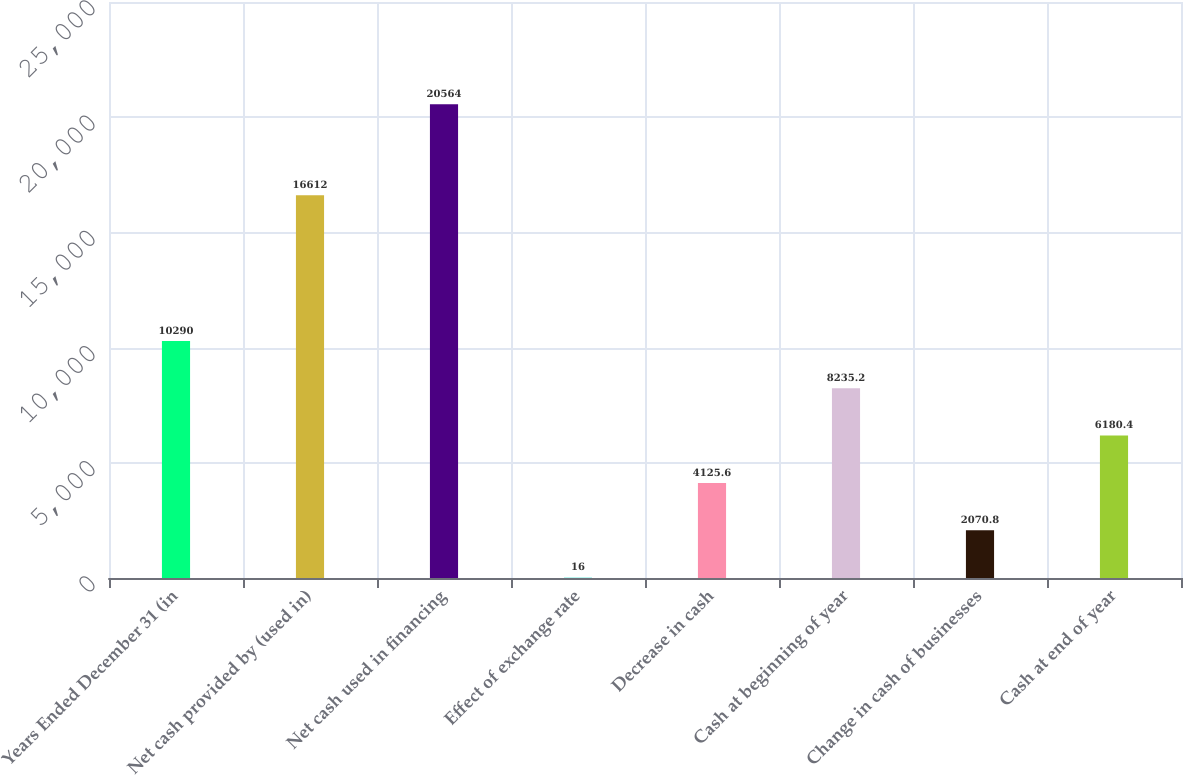Convert chart. <chart><loc_0><loc_0><loc_500><loc_500><bar_chart><fcel>Years Ended December 31 (in<fcel>Net cash provided by (used in)<fcel>Net cash used in financing<fcel>Effect of exchange rate<fcel>Decrease in cash<fcel>Cash at beginning of year<fcel>Change in cash of businesses<fcel>Cash at end of year<nl><fcel>10290<fcel>16612<fcel>20564<fcel>16<fcel>4125.6<fcel>8235.2<fcel>2070.8<fcel>6180.4<nl></chart> 